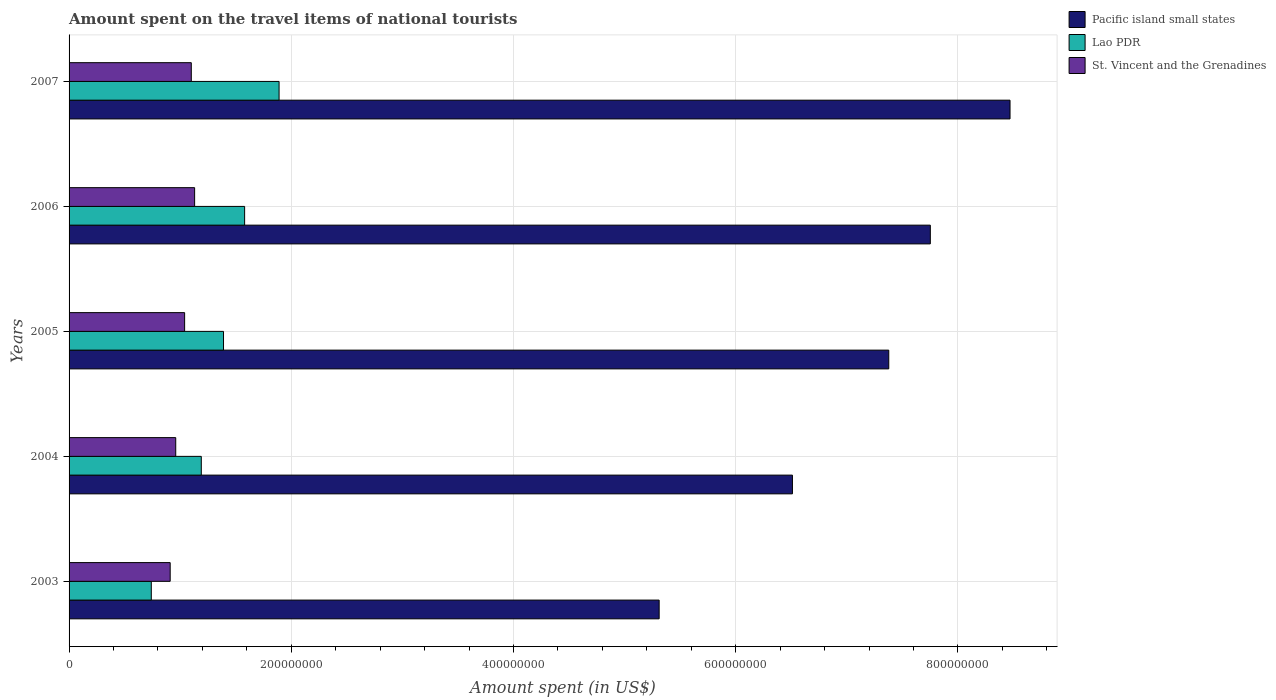How many bars are there on the 2nd tick from the bottom?
Provide a short and direct response. 3. What is the label of the 1st group of bars from the top?
Provide a short and direct response. 2007. In how many cases, is the number of bars for a given year not equal to the number of legend labels?
Offer a very short reply. 0. What is the amount spent on the travel items of national tourists in St. Vincent and the Grenadines in 2004?
Keep it short and to the point. 9.60e+07. Across all years, what is the maximum amount spent on the travel items of national tourists in St. Vincent and the Grenadines?
Ensure brevity in your answer.  1.13e+08. Across all years, what is the minimum amount spent on the travel items of national tourists in St. Vincent and the Grenadines?
Your answer should be compact. 9.10e+07. What is the total amount spent on the travel items of national tourists in St. Vincent and the Grenadines in the graph?
Provide a short and direct response. 5.14e+08. What is the difference between the amount spent on the travel items of national tourists in St. Vincent and the Grenadines in 2004 and that in 2007?
Give a very brief answer. -1.40e+07. What is the difference between the amount spent on the travel items of national tourists in St. Vincent and the Grenadines in 2004 and the amount spent on the travel items of national tourists in Lao PDR in 2003?
Ensure brevity in your answer.  2.20e+07. What is the average amount spent on the travel items of national tourists in Lao PDR per year?
Provide a succinct answer. 1.36e+08. In the year 2006, what is the difference between the amount spent on the travel items of national tourists in Pacific island small states and amount spent on the travel items of national tourists in St. Vincent and the Grenadines?
Offer a terse response. 6.62e+08. In how many years, is the amount spent on the travel items of national tourists in St. Vincent and the Grenadines greater than 120000000 US$?
Offer a very short reply. 0. What is the ratio of the amount spent on the travel items of national tourists in Lao PDR in 2003 to that in 2006?
Give a very brief answer. 0.47. Is the difference between the amount spent on the travel items of national tourists in Pacific island small states in 2004 and 2006 greater than the difference between the amount spent on the travel items of national tourists in St. Vincent and the Grenadines in 2004 and 2006?
Your response must be concise. No. What is the difference between the highest and the second highest amount spent on the travel items of national tourists in Pacific island small states?
Give a very brief answer. 7.17e+07. What is the difference between the highest and the lowest amount spent on the travel items of national tourists in Pacific island small states?
Ensure brevity in your answer.  3.16e+08. Is the sum of the amount spent on the travel items of national tourists in St. Vincent and the Grenadines in 2005 and 2006 greater than the maximum amount spent on the travel items of national tourists in Pacific island small states across all years?
Give a very brief answer. No. What does the 3rd bar from the top in 2003 represents?
Give a very brief answer. Pacific island small states. What does the 3rd bar from the bottom in 2003 represents?
Ensure brevity in your answer.  St. Vincent and the Grenadines. Is it the case that in every year, the sum of the amount spent on the travel items of national tourists in St. Vincent and the Grenadines and amount spent on the travel items of national tourists in Pacific island small states is greater than the amount spent on the travel items of national tourists in Lao PDR?
Provide a succinct answer. Yes. How many bars are there?
Keep it short and to the point. 15. Are all the bars in the graph horizontal?
Your answer should be very brief. Yes. Are the values on the major ticks of X-axis written in scientific E-notation?
Your response must be concise. No. Does the graph contain any zero values?
Provide a short and direct response. No. Does the graph contain grids?
Offer a very short reply. Yes. Where does the legend appear in the graph?
Keep it short and to the point. Top right. What is the title of the graph?
Give a very brief answer. Amount spent on the travel items of national tourists. Does "Germany" appear as one of the legend labels in the graph?
Give a very brief answer. No. What is the label or title of the X-axis?
Your answer should be compact. Amount spent (in US$). What is the label or title of the Y-axis?
Give a very brief answer. Years. What is the Amount spent (in US$) in Pacific island small states in 2003?
Keep it short and to the point. 5.31e+08. What is the Amount spent (in US$) of Lao PDR in 2003?
Give a very brief answer. 7.40e+07. What is the Amount spent (in US$) in St. Vincent and the Grenadines in 2003?
Provide a succinct answer. 9.10e+07. What is the Amount spent (in US$) in Pacific island small states in 2004?
Ensure brevity in your answer.  6.51e+08. What is the Amount spent (in US$) in Lao PDR in 2004?
Ensure brevity in your answer.  1.19e+08. What is the Amount spent (in US$) in St. Vincent and the Grenadines in 2004?
Provide a succinct answer. 9.60e+07. What is the Amount spent (in US$) in Pacific island small states in 2005?
Provide a short and direct response. 7.38e+08. What is the Amount spent (in US$) of Lao PDR in 2005?
Your response must be concise. 1.39e+08. What is the Amount spent (in US$) of St. Vincent and the Grenadines in 2005?
Provide a succinct answer. 1.04e+08. What is the Amount spent (in US$) in Pacific island small states in 2006?
Make the answer very short. 7.75e+08. What is the Amount spent (in US$) of Lao PDR in 2006?
Offer a terse response. 1.58e+08. What is the Amount spent (in US$) in St. Vincent and the Grenadines in 2006?
Provide a short and direct response. 1.13e+08. What is the Amount spent (in US$) of Pacific island small states in 2007?
Your answer should be compact. 8.47e+08. What is the Amount spent (in US$) in Lao PDR in 2007?
Give a very brief answer. 1.89e+08. What is the Amount spent (in US$) in St. Vincent and the Grenadines in 2007?
Provide a succinct answer. 1.10e+08. Across all years, what is the maximum Amount spent (in US$) of Pacific island small states?
Your answer should be compact. 8.47e+08. Across all years, what is the maximum Amount spent (in US$) of Lao PDR?
Provide a succinct answer. 1.89e+08. Across all years, what is the maximum Amount spent (in US$) in St. Vincent and the Grenadines?
Keep it short and to the point. 1.13e+08. Across all years, what is the minimum Amount spent (in US$) of Pacific island small states?
Your answer should be compact. 5.31e+08. Across all years, what is the minimum Amount spent (in US$) of Lao PDR?
Give a very brief answer. 7.40e+07. Across all years, what is the minimum Amount spent (in US$) in St. Vincent and the Grenadines?
Ensure brevity in your answer.  9.10e+07. What is the total Amount spent (in US$) in Pacific island small states in the graph?
Make the answer very short. 3.54e+09. What is the total Amount spent (in US$) in Lao PDR in the graph?
Offer a very short reply. 6.79e+08. What is the total Amount spent (in US$) in St. Vincent and the Grenadines in the graph?
Give a very brief answer. 5.14e+08. What is the difference between the Amount spent (in US$) in Pacific island small states in 2003 and that in 2004?
Offer a very short reply. -1.20e+08. What is the difference between the Amount spent (in US$) in Lao PDR in 2003 and that in 2004?
Provide a succinct answer. -4.50e+07. What is the difference between the Amount spent (in US$) of St. Vincent and the Grenadines in 2003 and that in 2004?
Your answer should be very brief. -5.00e+06. What is the difference between the Amount spent (in US$) in Pacific island small states in 2003 and that in 2005?
Your response must be concise. -2.07e+08. What is the difference between the Amount spent (in US$) in Lao PDR in 2003 and that in 2005?
Your answer should be very brief. -6.50e+07. What is the difference between the Amount spent (in US$) of St. Vincent and the Grenadines in 2003 and that in 2005?
Keep it short and to the point. -1.30e+07. What is the difference between the Amount spent (in US$) in Pacific island small states in 2003 and that in 2006?
Make the answer very short. -2.44e+08. What is the difference between the Amount spent (in US$) of Lao PDR in 2003 and that in 2006?
Your response must be concise. -8.40e+07. What is the difference between the Amount spent (in US$) of St. Vincent and the Grenadines in 2003 and that in 2006?
Provide a succinct answer. -2.20e+07. What is the difference between the Amount spent (in US$) of Pacific island small states in 2003 and that in 2007?
Ensure brevity in your answer.  -3.16e+08. What is the difference between the Amount spent (in US$) of Lao PDR in 2003 and that in 2007?
Your answer should be compact. -1.15e+08. What is the difference between the Amount spent (in US$) in St. Vincent and the Grenadines in 2003 and that in 2007?
Provide a succinct answer. -1.90e+07. What is the difference between the Amount spent (in US$) in Pacific island small states in 2004 and that in 2005?
Provide a succinct answer. -8.67e+07. What is the difference between the Amount spent (in US$) in Lao PDR in 2004 and that in 2005?
Your answer should be compact. -2.00e+07. What is the difference between the Amount spent (in US$) in St. Vincent and the Grenadines in 2004 and that in 2005?
Your answer should be very brief. -8.00e+06. What is the difference between the Amount spent (in US$) in Pacific island small states in 2004 and that in 2006?
Provide a succinct answer. -1.24e+08. What is the difference between the Amount spent (in US$) in Lao PDR in 2004 and that in 2006?
Your answer should be very brief. -3.90e+07. What is the difference between the Amount spent (in US$) of St. Vincent and the Grenadines in 2004 and that in 2006?
Provide a short and direct response. -1.70e+07. What is the difference between the Amount spent (in US$) in Pacific island small states in 2004 and that in 2007?
Keep it short and to the point. -1.96e+08. What is the difference between the Amount spent (in US$) of Lao PDR in 2004 and that in 2007?
Offer a very short reply. -7.00e+07. What is the difference between the Amount spent (in US$) in St. Vincent and the Grenadines in 2004 and that in 2007?
Offer a very short reply. -1.40e+07. What is the difference between the Amount spent (in US$) of Pacific island small states in 2005 and that in 2006?
Ensure brevity in your answer.  -3.74e+07. What is the difference between the Amount spent (in US$) in Lao PDR in 2005 and that in 2006?
Make the answer very short. -1.90e+07. What is the difference between the Amount spent (in US$) in St. Vincent and the Grenadines in 2005 and that in 2006?
Provide a succinct answer. -9.00e+06. What is the difference between the Amount spent (in US$) in Pacific island small states in 2005 and that in 2007?
Offer a terse response. -1.09e+08. What is the difference between the Amount spent (in US$) of Lao PDR in 2005 and that in 2007?
Your answer should be very brief. -5.00e+07. What is the difference between the Amount spent (in US$) in St. Vincent and the Grenadines in 2005 and that in 2007?
Your answer should be compact. -6.00e+06. What is the difference between the Amount spent (in US$) of Pacific island small states in 2006 and that in 2007?
Your answer should be compact. -7.17e+07. What is the difference between the Amount spent (in US$) of Lao PDR in 2006 and that in 2007?
Ensure brevity in your answer.  -3.10e+07. What is the difference between the Amount spent (in US$) of Pacific island small states in 2003 and the Amount spent (in US$) of Lao PDR in 2004?
Provide a succinct answer. 4.12e+08. What is the difference between the Amount spent (in US$) of Pacific island small states in 2003 and the Amount spent (in US$) of St. Vincent and the Grenadines in 2004?
Your response must be concise. 4.35e+08. What is the difference between the Amount spent (in US$) in Lao PDR in 2003 and the Amount spent (in US$) in St. Vincent and the Grenadines in 2004?
Your answer should be very brief. -2.20e+07. What is the difference between the Amount spent (in US$) in Pacific island small states in 2003 and the Amount spent (in US$) in Lao PDR in 2005?
Your response must be concise. 3.92e+08. What is the difference between the Amount spent (in US$) of Pacific island small states in 2003 and the Amount spent (in US$) of St. Vincent and the Grenadines in 2005?
Offer a very short reply. 4.27e+08. What is the difference between the Amount spent (in US$) in Lao PDR in 2003 and the Amount spent (in US$) in St. Vincent and the Grenadines in 2005?
Keep it short and to the point. -3.00e+07. What is the difference between the Amount spent (in US$) of Pacific island small states in 2003 and the Amount spent (in US$) of Lao PDR in 2006?
Ensure brevity in your answer.  3.73e+08. What is the difference between the Amount spent (in US$) in Pacific island small states in 2003 and the Amount spent (in US$) in St. Vincent and the Grenadines in 2006?
Your answer should be very brief. 4.18e+08. What is the difference between the Amount spent (in US$) in Lao PDR in 2003 and the Amount spent (in US$) in St. Vincent and the Grenadines in 2006?
Keep it short and to the point. -3.90e+07. What is the difference between the Amount spent (in US$) of Pacific island small states in 2003 and the Amount spent (in US$) of Lao PDR in 2007?
Keep it short and to the point. 3.42e+08. What is the difference between the Amount spent (in US$) in Pacific island small states in 2003 and the Amount spent (in US$) in St. Vincent and the Grenadines in 2007?
Make the answer very short. 4.21e+08. What is the difference between the Amount spent (in US$) in Lao PDR in 2003 and the Amount spent (in US$) in St. Vincent and the Grenadines in 2007?
Ensure brevity in your answer.  -3.60e+07. What is the difference between the Amount spent (in US$) in Pacific island small states in 2004 and the Amount spent (in US$) in Lao PDR in 2005?
Offer a terse response. 5.12e+08. What is the difference between the Amount spent (in US$) of Pacific island small states in 2004 and the Amount spent (in US$) of St. Vincent and the Grenadines in 2005?
Your answer should be very brief. 5.47e+08. What is the difference between the Amount spent (in US$) of Lao PDR in 2004 and the Amount spent (in US$) of St. Vincent and the Grenadines in 2005?
Provide a short and direct response. 1.50e+07. What is the difference between the Amount spent (in US$) in Pacific island small states in 2004 and the Amount spent (in US$) in Lao PDR in 2006?
Keep it short and to the point. 4.93e+08. What is the difference between the Amount spent (in US$) in Pacific island small states in 2004 and the Amount spent (in US$) in St. Vincent and the Grenadines in 2006?
Your answer should be compact. 5.38e+08. What is the difference between the Amount spent (in US$) in Lao PDR in 2004 and the Amount spent (in US$) in St. Vincent and the Grenadines in 2006?
Keep it short and to the point. 6.00e+06. What is the difference between the Amount spent (in US$) in Pacific island small states in 2004 and the Amount spent (in US$) in Lao PDR in 2007?
Provide a succinct answer. 4.62e+08. What is the difference between the Amount spent (in US$) of Pacific island small states in 2004 and the Amount spent (in US$) of St. Vincent and the Grenadines in 2007?
Make the answer very short. 5.41e+08. What is the difference between the Amount spent (in US$) of Lao PDR in 2004 and the Amount spent (in US$) of St. Vincent and the Grenadines in 2007?
Your response must be concise. 9.00e+06. What is the difference between the Amount spent (in US$) of Pacific island small states in 2005 and the Amount spent (in US$) of Lao PDR in 2006?
Make the answer very short. 5.80e+08. What is the difference between the Amount spent (in US$) in Pacific island small states in 2005 and the Amount spent (in US$) in St. Vincent and the Grenadines in 2006?
Your response must be concise. 6.25e+08. What is the difference between the Amount spent (in US$) in Lao PDR in 2005 and the Amount spent (in US$) in St. Vincent and the Grenadines in 2006?
Make the answer very short. 2.60e+07. What is the difference between the Amount spent (in US$) of Pacific island small states in 2005 and the Amount spent (in US$) of Lao PDR in 2007?
Make the answer very short. 5.49e+08. What is the difference between the Amount spent (in US$) of Pacific island small states in 2005 and the Amount spent (in US$) of St. Vincent and the Grenadines in 2007?
Your answer should be very brief. 6.28e+08. What is the difference between the Amount spent (in US$) of Lao PDR in 2005 and the Amount spent (in US$) of St. Vincent and the Grenadines in 2007?
Offer a terse response. 2.90e+07. What is the difference between the Amount spent (in US$) in Pacific island small states in 2006 and the Amount spent (in US$) in Lao PDR in 2007?
Your response must be concise. 5.86e+08. What is the difference between the Amount spent (in US$) of Pacific island small states in 2006 and the Amount spent (in US$) of St. Vincent and the Grenadines in 2007?
Your response must be concise. 6.65e+08. What is the difference between the Amount spent (in US$) of Lao PDR in 2006 and the Amount spent (in US$) of St. Vincent and the Grenadines in 2007?
Ensure brevity in your answer.  4.80e+07. What is the average Amount spent (in US$) in Pacific island small states per year?
Make the answer very short. 7.08e+08. What is the average Amount spent (in US$) in Lao PDR per year?
Make the answer very short. 1.36e+08. What is the average Amount spent (in US$) of St. Vincent and the Grenadines per year?
Provide a short and direct response. 1.03e+08. In the year 2003, what is the difference between the Amount spent (in US$) of Pacific island small states and Amount spent (in US$) of Lao PDR?
Keep it short and to the point. 4.57e+08. In the year 2003, what is the difference between the Amount spent (in US$) of Pacific island small states and Amount spent (in US$) of St. Vincent and the Grenadines?
Provide a short and direct response. 4.40e+08. In the year 2003, what is the difference between the Amount spent (in US$) of Lao PDR and Amount spent (in US$) of St. Vincent and the Grenadines?
Your answer should be compact. -1.70e+07. In the year 2004, what is the difference between the Amount spent (in US$) in Pacific island small states and Amount spent (in US$) in Lao PDR?
Make the answer very short. 5.32e+08. In the year 2004, what is the difference between the Amount spent (in US$) in Pacific island small states and Amount spent (in US$) in St. Vincent and the Grenadines?
Make the answer very short. 5.55e+08. In the year 2004, what is the difference between the Amount spent (in US$) in Lao PDR and Amount spent (in US$) in St. Vincent and the Grenadines?
Offer a very short reply. 2.30e+07. In the year 2005, what is the difference between the Amount spent (in US$) of Pacific island small states and Amount spent (in US$) of Lao PDR?
Keep it short and to the point. 5.99e+08. In the year 2005, what is the difference between the Amount spent (in US$) in Pacific island small states and Amount spent (in US$) in St. Vincent and the Grenadines?
Provide a short and direct response. 6.34e+08. In the year 2005, what is the difference between the Amount spent (in US$) in Lao PDR and Amount spent (in US$) in St. Vincent and the Grenadines?
Your answer should be compact. 3.50e+07. In the year 2006, what is the difference between the Amount spent (in US$) of Pacific island small states and Amount spent (in US$) of Lao PDR?
Offer a terse response. 6.17e+08. In the year 2006, what is the difference between the Amount spent (in US$) in Pacific island small states and Amount spent (in US$) in St. Vincent and the Grenadines?
Offer a very short reply. 6.62e+08. In the year 2006, what is the difference between the Amount spent (in US$) in Lao PDR and Amount spent (in US$) in St. Vincent and the Grenadines?
Keep it short and to the point. 4.50e+07. In the year 2007, what is the difference between the Amount spent (in US$) in Pacific island small states and Amount spent (in US$) in Lao PDR?
Ensure brevity in your answer.  6.58e+08. In the year 2007, what is the difference between the Amount spent (in US$) in Pacific island small states and Amount spent (in US$) in St. Vincent and the Grenadines?
Give a very brief answer. 7.37e+08. In the year 2007, what is the difference between the Amount spent (in US$) in Lao PDR and Amount spent (in US$) in St. Vincent and the Grenadines?
Ensure brevity in your answer.  7.90e+07. What is the ratio of the Amount spent (in US$) of Pacific island small states in 2003 to that in 2004?
Provide a short and direct response. 0.82. What is the ratio of the Amount spent (in US$) of Lao PDR in 2003 to that in 2004?
Provide a succinct answer. 0.62. What is the ratio of the Amount spent (in US$) of St. Vincent and the Grenadines in 2003 to that in 2004?
Your answer should be very brief. 0.95. What is the ratio of the Amount spent (in US$) in Pacific island small states in 2003 to that in 2005?
Your response must be concise. 0.72. What is the ratio of the Amount spent (in US$) of Lao PDR in 2003 to that in 2005?
Ensure brevity in your answer.  0.53. What is the ratio of the Amount spent (in US$) of Pacific island small states in 2003 to that in 2006?
Ensure brevity in your answer.  0.69. What is the ratio of the Amount spent (in US$) in Lao PDR in 2003 to that in 2006?
Provide a succinct answer. 0.47. What is the ratio of the Amount spent (in US$) in St. Vincent and the Grenadines in 2003 to that in 2006?
Your response must be concise. 0.81. What is the ratio of the Amount spent (in US$) of Pacific island small states in 2003 to that in 2007?
Make the answer very short. 0.63. What is the ratio of the Amount spent (in US$) in Lao PDR in 2003 to that in 2007?
Your answer should be compact. 0.39. What is the ratio of the Amount spent (in US$) of St. Vincent and the Grenadines in 2003 to that in 2007?
Your answer should be very brief. 0.83. What is the ratio of the Amount spent (in US$) in Pacific island small states in 2004 to that in 2005?
Your answer should be very brief. 0.88. What is the ratio of the Amount spent (in US$) in Lao PDR in 2004 to that in 2005?
Offer a terse response. 0.86. What is the ratio of the Amount spent (in US$) of Pacific island small states in 2004 to that in 2006?
Provide a succinct answer. 0.84. What is the ratio of the Amount spent (in US$) in Lao PDR in 2004 to that in 2006?
Give a very brief answer. 0.75. What is the ratio of the Amount spent (in US$) in St. Vincent and the Grenadines in 2004 to that in 2006?
Keep it short and to the point. 0.85. What is the ratio of the Amount spent (in US$) in Pacific island small states in 2004 to that in 2007?
Offer a very short reply. 0.77. What is the ratio of the Amount spent (in US$) of Lao PDR in 2004 to that in 2007?
Offer a terse response. 0.63. What is the ratio of the Amount spent (in US$) of St. Vincent and the Grenadines in 2004 to that in 2007?
Give a very brief answer. 0.87. What is the ratio of the Amount spent (in US$) of Pacific island small states in 2005 to that in 2006?
Give a very brief answer. 0.95. What is the ratio of the Amount spent (in US$) of Lao PDR in 2005 to that in 2006?
Provide a succinct answer. 0.88. What is the ratio of the Amount spent (in US$) of St. Vincent and the Grenadines in 2005 to that in 2006?
Your answer should be compact. 0.92. What is the ratio of the Amount spent (in US$) of Pacific island small states in 2005 to that in 2007?
Your answer should be very brief. 0.87. What is the ratio of the Amount spent (in US$) of Lao PDR in 2005 to that in 2007?
Keep it short and to the point. 0.74. What is the ratio of the Amount spent (in US$) of St. Vincent and the Grenadines in 2005 to that in 2007?
Your answer should be compact. 0.95. What is the ratio of the Amount spent (in US$) of Pacific island small states in 2006 to that in 2007?
Provide a succinct answer. 0.92. What is the ratio of the Amount spent (in US$) of Lao PDR in 2006 to that in 2007?
Your answer should be very brief. 0.84. What is the ratio of the Amount spent (in US$) in St. Vincent and the Grenadines in 2006 to that in 2007?
Keep it short and to the point. 1.03. What is the difference between the highest and the second highest Amount spent (in US$) in Pacific island small states?
Ensure brevity in your answer.  7.17e+07. What is the difference between the highest and the second highest Amount spent (in US$) in Lao PDR?
Provide a succinct answer. 3.10e+07. What is the difference between the highest and the second highest Amount spent (in US$) in St. Vincent and the Grenadines?
Make the answer very short. 3.00e+06. What is the difference between the highest and the lowest Amount spent (in US$) of Pacific island small states?
Ensure brevity in your answer.  3.16e+08. What is the difference between the highest and the lowest Amount spent (in US$) of Lao PDR?
Provide a succinct answer. 1.15e+08. What is the difference between the highest and the lowest Amount spent (in US$) in St. Vincent and the Grenadines?
Your answer should be compact. 2.20e+07. 